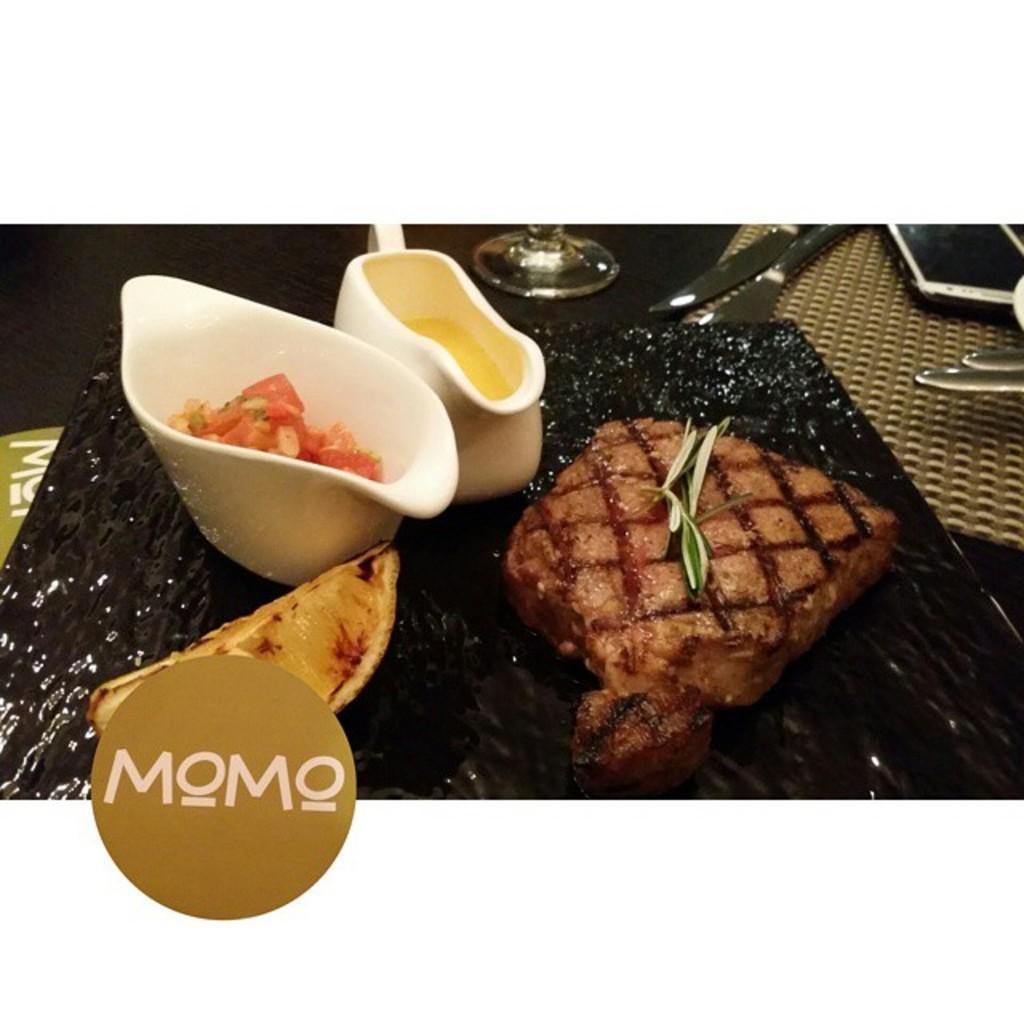Could you give a brief overview of what you see in this image? There are some food items and two white color bowls are present on a black color surface in the middle of this image, and there is a logo at the bottom of this image. There is a mobile and some spoons are present in the top right corner of this image. 